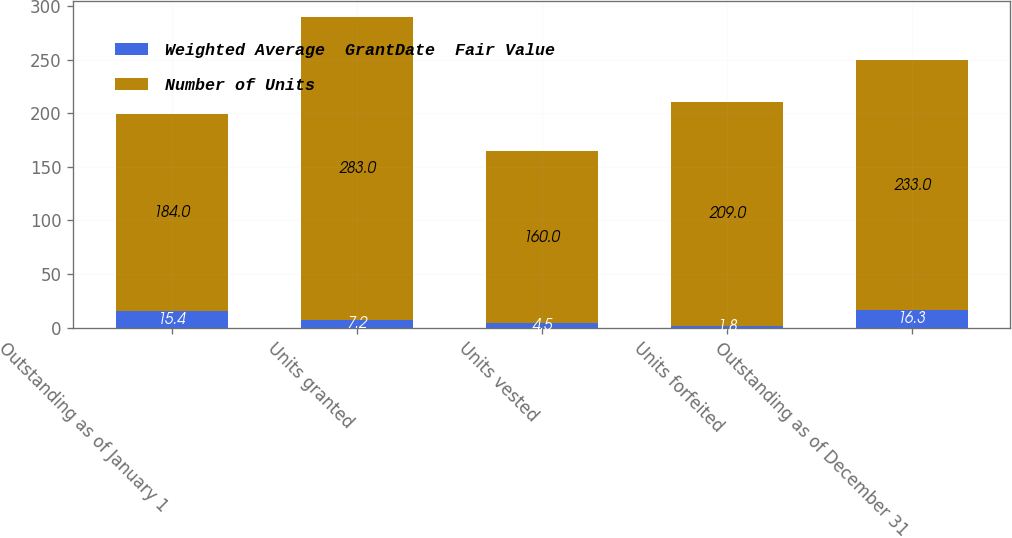Convert chart to OTSL. <chart><loc_0><loc_0><loc_500><loc_500><stacked_bar_chart><ecel><fcel>Outstanding as of January 1<fcel>Units granted<fcel>Units vested<fcel>Units forfeited<fcel>Outstanding as of December 31<nl><fcel>Weighted Average  GrantDate  Fair Value<fcel>15.4<fcel>7.2<fcel>4.5<fcel>1.8<fcel>16.3<nl><fcel>Number of Units<fcel>184<fcel>283<fcel>160<fcel>209<fcel>233<nl></chart> 